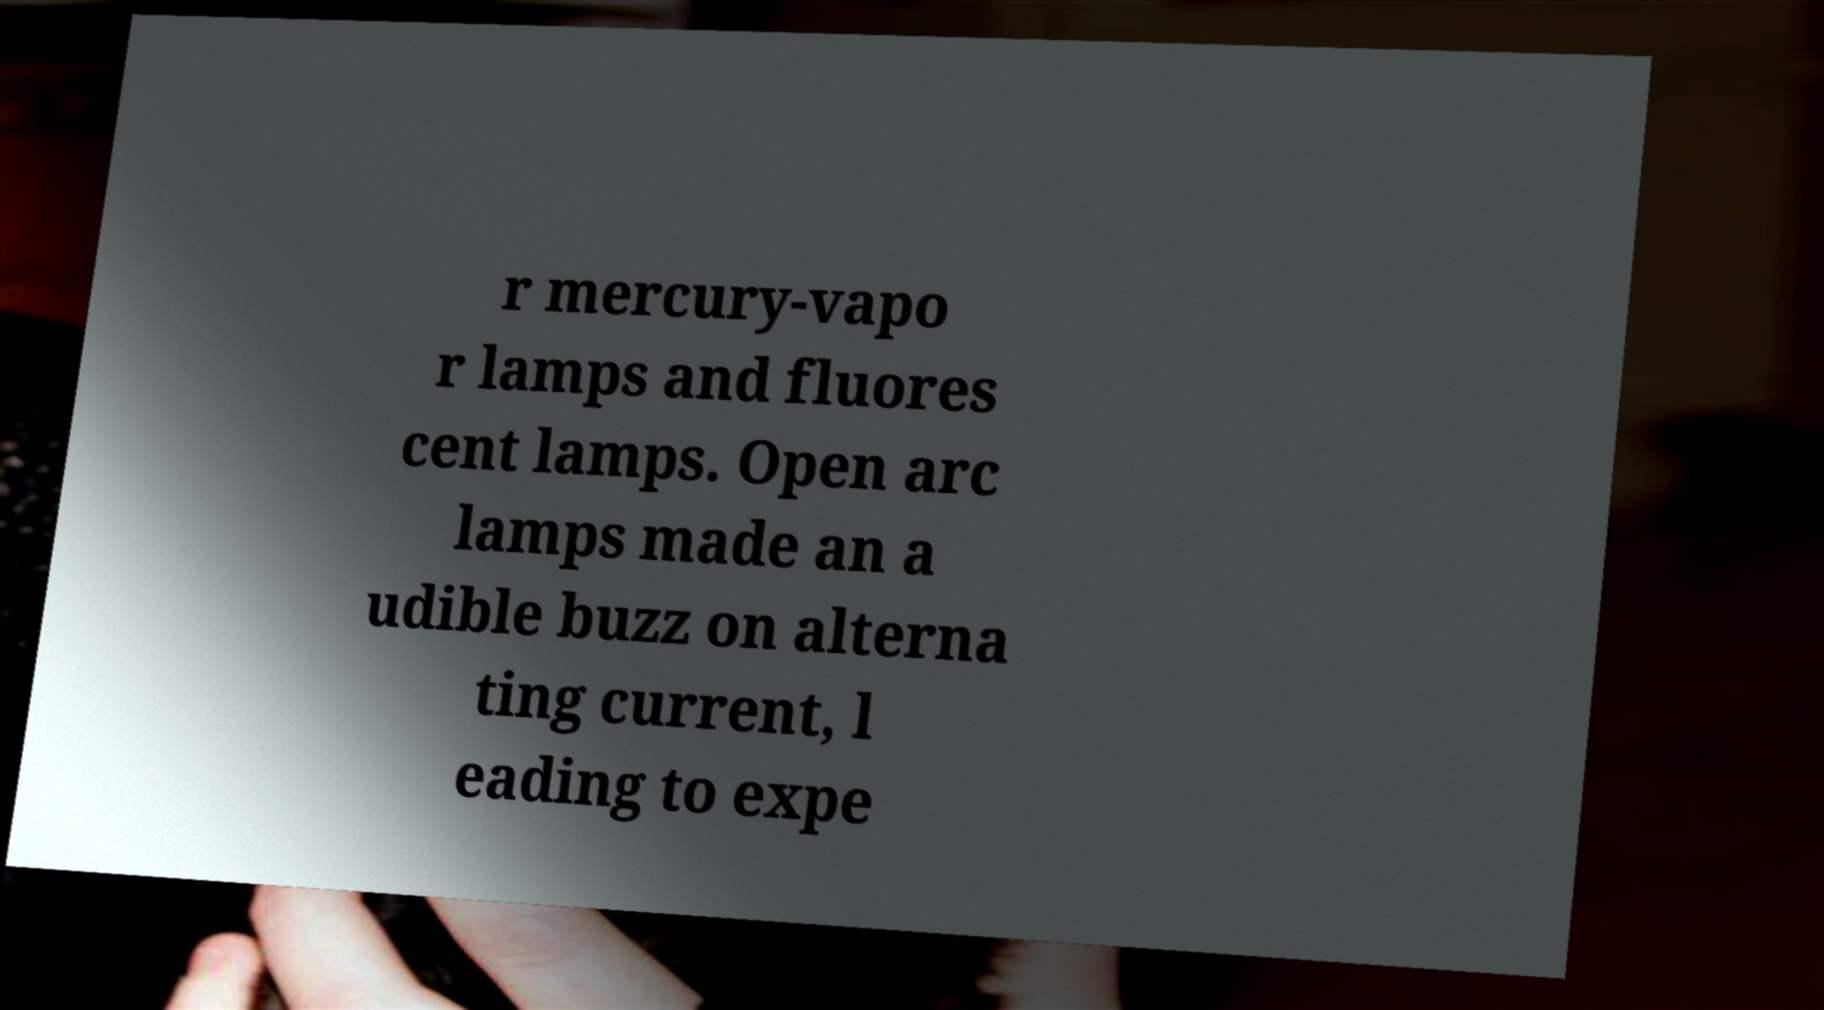Can you accurately transcribe the text from the provided image for me? r mercury-vapo r lamps and fluores cent lamps. Open arc lamps made an a udible buzz on alterna ting current, l eading to expe 